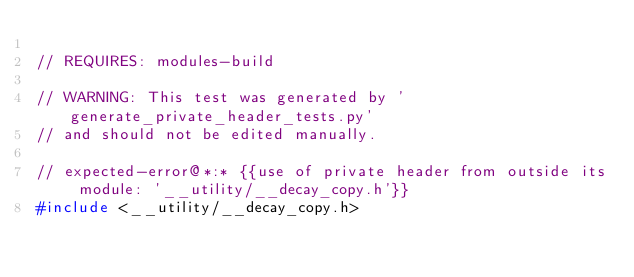<code> <loc_0><loc_0><loc_500><loc_500><_C++_>
// REQUIRES: modules-build

// WARNING: This test was generated by 'generate_private_header_tests.py'
// and should not be edited manually.

// expected-error@*:* {{use of private header from outside its module: '__utility/__decay_copy.h'}}
#include <__utility/__decay_copy.h>
</code> 